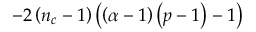<formula> <loc_0><loc_0><loc_500><loc_500>- 2 \left ( n _ { c } - 1 \right ) \left ( \left ( \alpha - 1 \right ) \left ( p - 1 \right ) - 1 \right )</formula> 